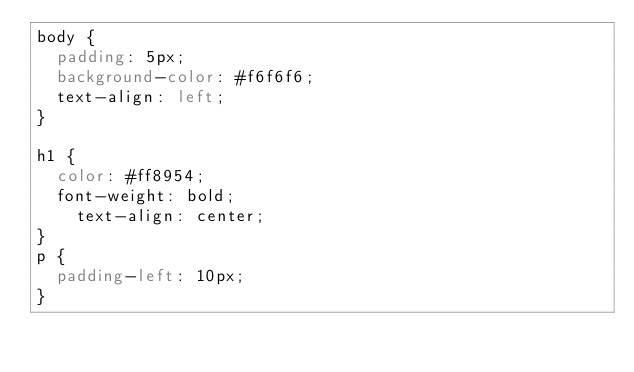<code> <loc_0><loc_0><loc_500><loc_500><_CSS_>body {
  padding: 5px;
  background-color: #f6f6f6;
  text-align: left;
}

h1 {
  color: #ff8954;
  font-weight: bold;
    text-align: center;
}
p {
  padding-left: 10px;
}
</code> 